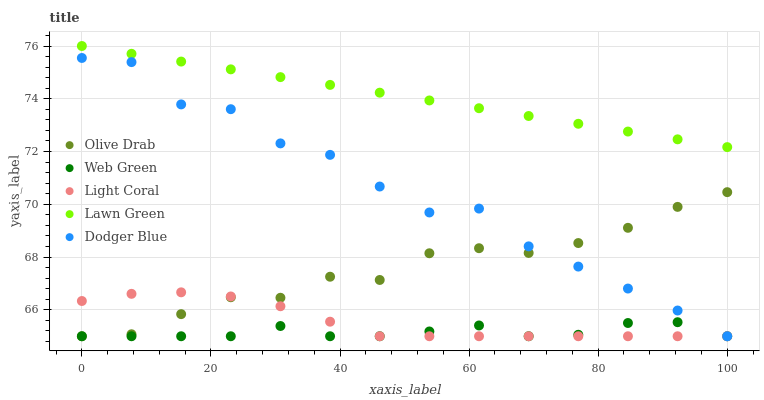Does Web Green have the minimum area under the curve?
Answer yes or no. Yes. Does Lawn Green have the maximum area under the curve?
Answer yes or no. Yes. Does Dodger Blue have the minimum area under the curve?
Answer yes or no. No. Does Dodger Blue have the maximum area under the curve?
Answer yes or no. No. Is Lawn Green the smoothest?
Answer yes or no. Yes. Is Dodger Blue the roughest?
Answer yes or no. Yes. Is Dodger Blue the smoothest?
Answer yes or no. No. Is Lawn Green the roughest?
Answer yes or no. No. Does Light Coral have the lowest value?
Answer yes or no. Yes. Does Lawn Green have the lowest value?
Answer yes or no. No. Does Lawn Green have the highest value?
Answer yes or no. Yes. Does Dodger Blue have the highest value?
Answer yes or no. No. Is Light Coral less than Lawn Green?
Answer yes or no. Yes. Is Lawn Green greater than Light Coral?
Answer yes or no. Yes. Does Olive Drab intersect Dodger Blue?
Answer yes or no. Yes. Is Olive Drab less than Dodger Blue?
Answer yes or no. No. Is Olive Drab greater than Dodger Blue?
Answer yes or no. No. Does Light Coral intersect Lawn Green?
Answer yes or no. No. 